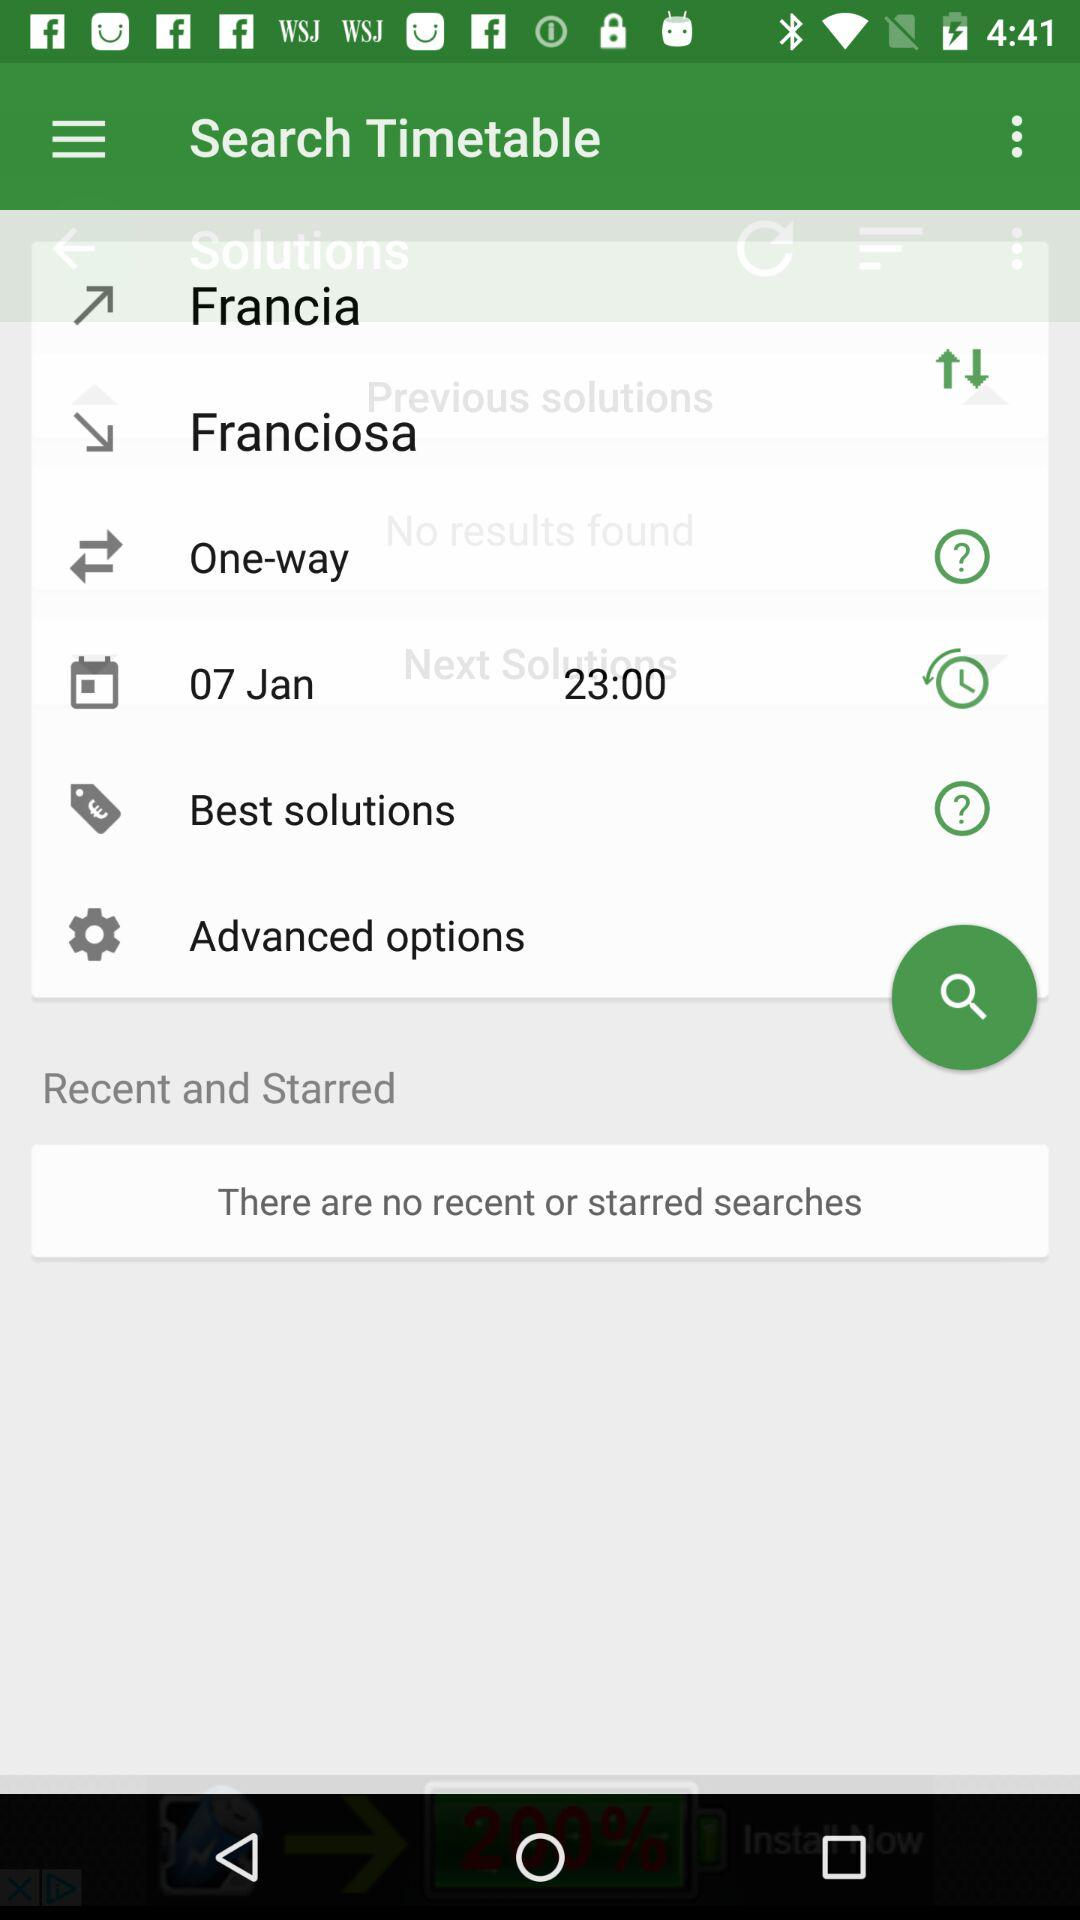What is the final destination? The final destination is "Franciosa". 